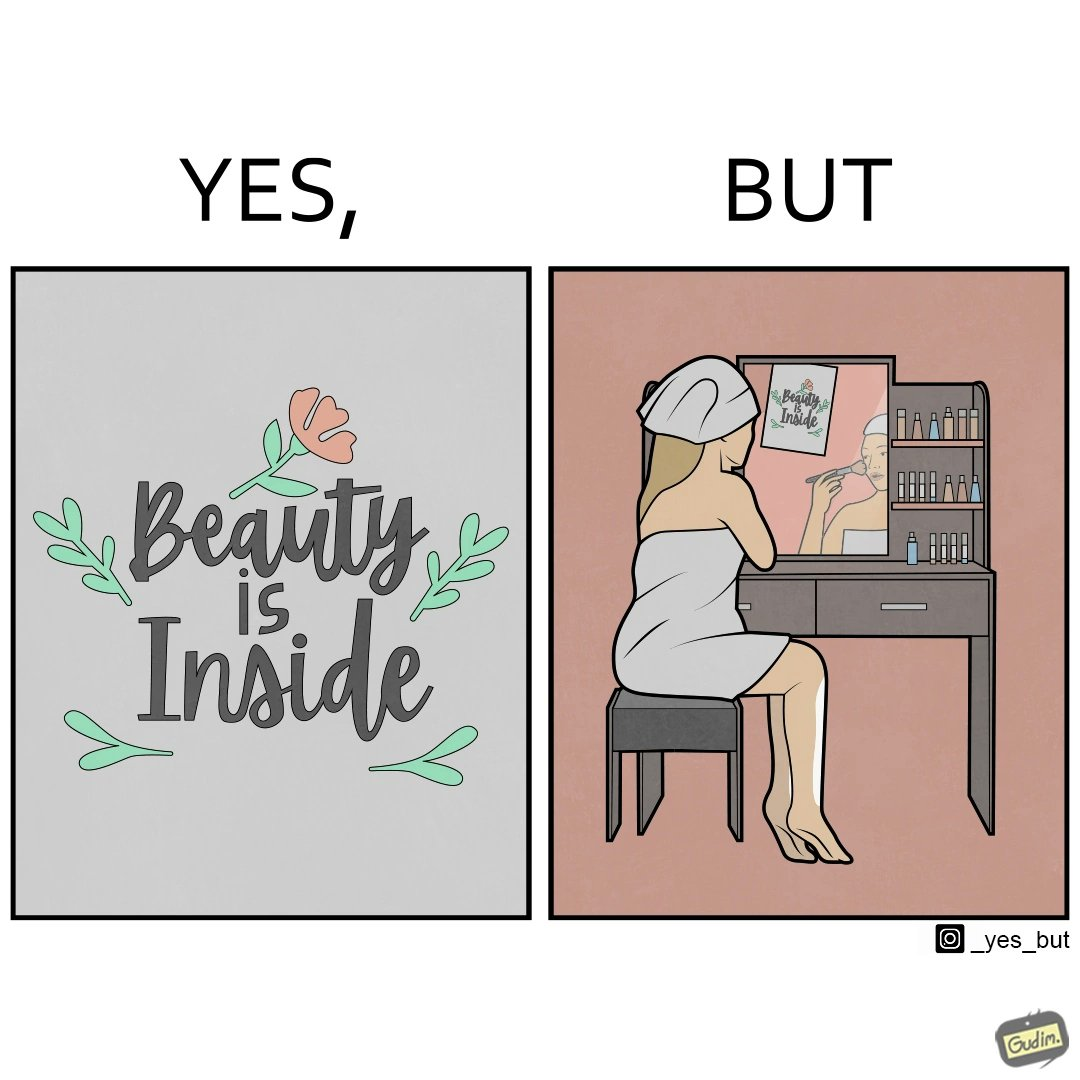Is this a satirical image? Yes, this image is satirical. 